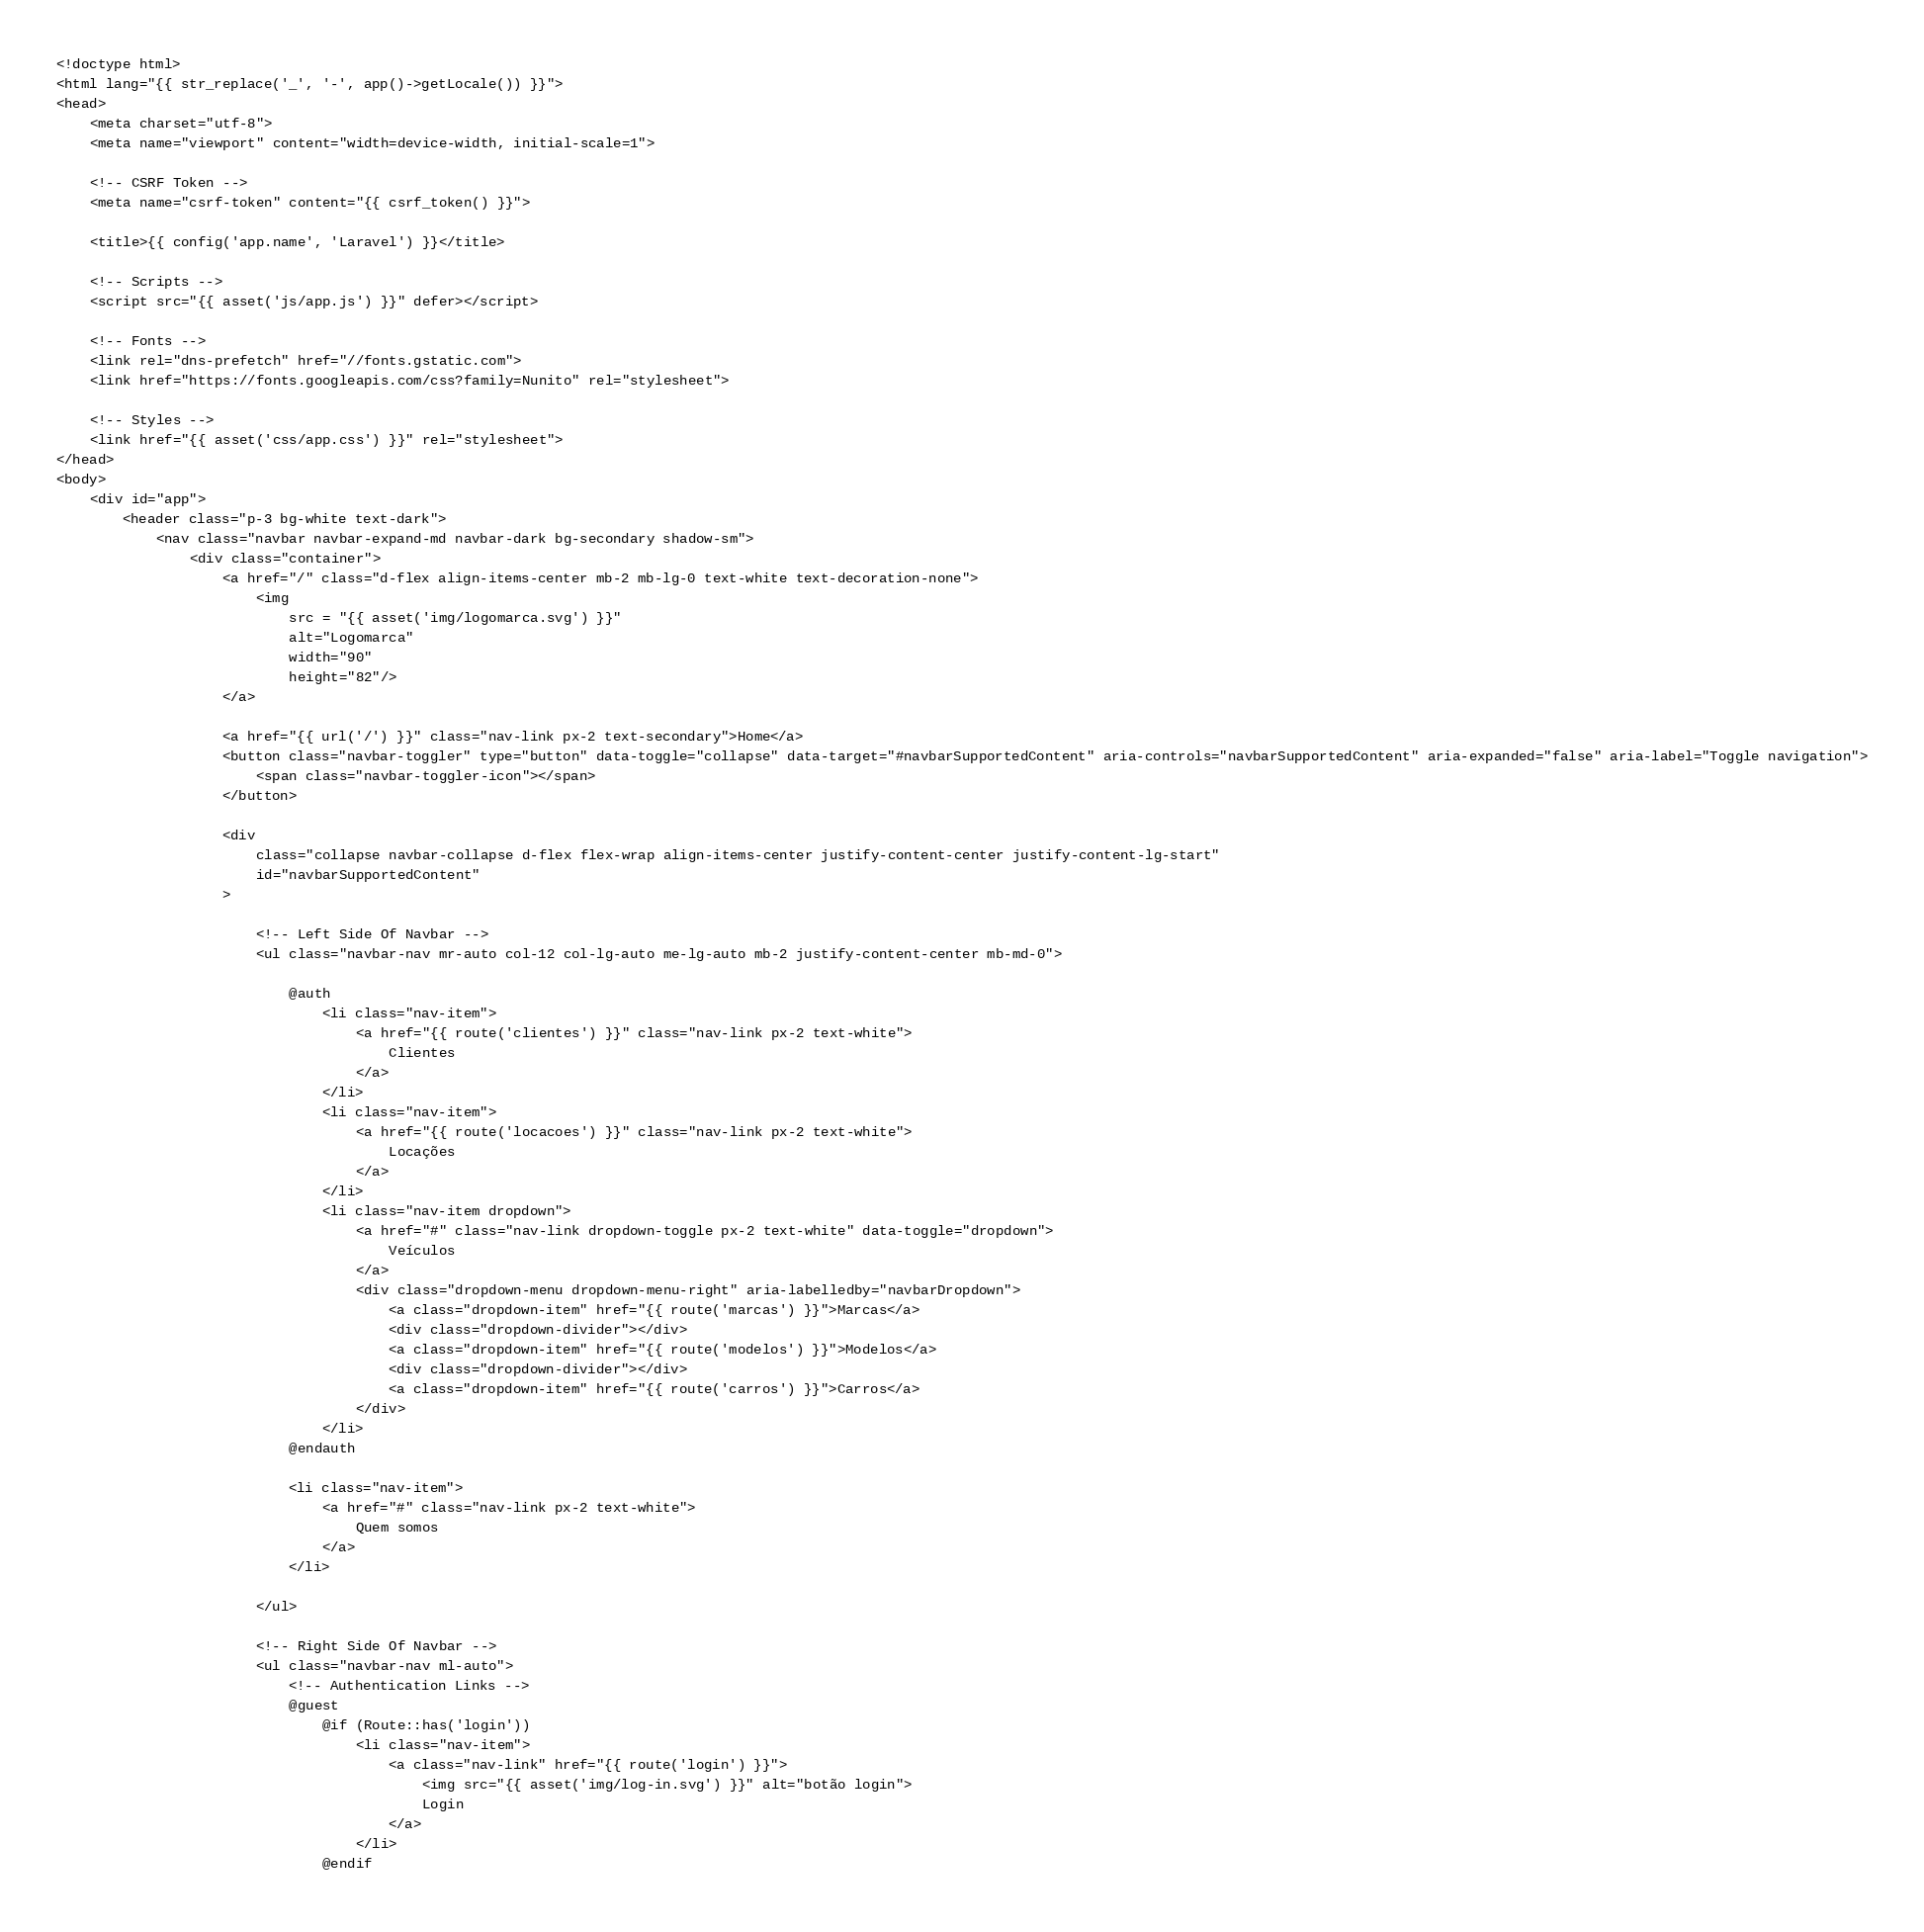Convert code to text. <code><loc_0><loc_0><loc_500><loc_500><_PHP_><!doctype html>
<html lang="{{ str_replace('_', '-', app()->getLocale()) }}">
<head>
    <meta charset="utf-8">
    <meta name="viewport" content="width=device-width, initial-scale=1">

    <!-- CSRF Token -->
    <meta name="csrf-token" content="{{ csrf_token() }}">

    <title>{{ config('app.name', 'Laravel') }}</title>

    <!-- Scripts -->
    <script src="{{ asset('js/app.js') }}" defer></script>

    <!-- Fonts -->
    <link rel="dns-prefetch" href="//fonts.gstatic.com">
    <link href="https://fonts.googleapis.com/css?family=Nunito" rel="stylesheet">

    <!-- Styles -->
    <link href="{{ asset('css/app.css') }}" rel="stylesheet">
</head>
<body>
    <div id="app">
        <header class="p-3 bg-white text-dark">
            <nav class="navbar navbar-expand-md navbar-dark bg-secondary shadow-sm">
                <div class="container">
                    <a href="/" class="d-flex align-items-center mb-2 mb-lg-0 text-white text-decoration-none">
                        <img
                            src = "{{ asset('img/logomarca.svg') }}"
                            alt="Logomarca"
                            width="90"
                            height="82"/>
                    </a>

                    <a href="{{ url('/') }}" class="nav-link px-2 text-secondary">Home</a>
                    <button class="navbar-toggler" type="button" data-toggle="collapse" data-target="#navbarSupportedContent" aria-controls="navbarSupportedContent" aria-expanded="false" aria-label="Toggle navigation">
                        <span class="navbar-toggler-icon"></span>
                    </button>

                    <div
                        class="collapse navbar-collapse d-flex flex-wrap align-items-center justify-content-center justify-content-lg-start"
                        id="navbarSupportedContent"
                    >

                        <!-- Left Side Of Navbar -->
                        <ul class="navbar-nav mr-auto col-12 col-lg-auto me-lg-auto mb-2 justify-content-center mb-md-0">

                            @auth
                                <li class="nav-item">
                                    <a href="{{ route('clientes') }}" class="nav-link px-2 text-white">
                                        Clientes
                                    </a>
                                </li>
                                <li class="nav-item">
                                    <a href="{{ route('locacoes') }}" class="nav-link px-2 text-white">
                                        Locações
                                    </a>
                                </li>
                                <li class="nav-item dropdown">
                                    <a href="#" class="nav-link dropdown-toggle px-2 text-white" data-toggle="dropdown">
                                        Veículos
                                    </a>
                                    <div class="dropdown-menu dropdown-menu-right" aria-labelledby="navbarDropdown">
                                        <a class="dropdown-item" href="{{ route('marcas') }}">Marcas</a>
                                        <div class="dropdown-divider"></div>
                                        <a class="dropdown-item" href="{{ route('modelos') }}">Modelos</a>
                                        <div class="dropdown-divider"></div>
                                        <a class="dropdown-item" href="{{ route('carros') }}">Carros</a>
                                    </div>
                                </li>
                            @endauth

                            <li class="nav-item">
                                <a href="#" class="nav-link px-2 text-white">
                                    Quem somos
                                </a>
                            </li>

                        </ul>

                        <!-- Right Side Of Navbar -->
                        <ul class="navbar-nav ml-auto">
                            <!-- Authentication Links -->
                            @guest
                                @if (Route::has('login'))
                                    <li class="nav-item">
                                        <a class="nav-link" href="{{ route('login') }}">
                                            <img src="{{ asset('img/log-in.svg') }}" alt="botão login">
                                            Login
                                        </a>
                                    </li>
                                @endif
</code> 